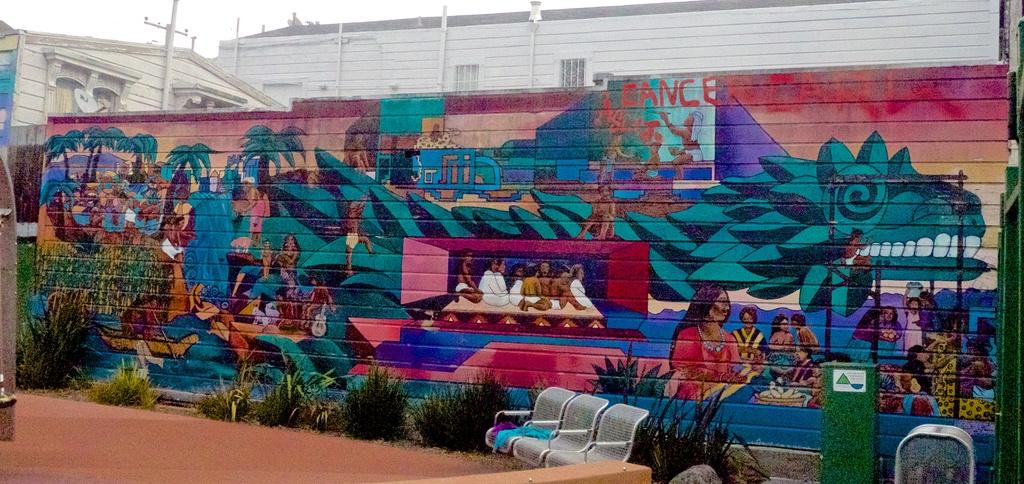What type of structures can be seen in the image? There are buildings in the image. What other elements are present in the image besides buildings? There are plants, chairs, poles, and other objects in the image. Can you describe the graffiti in the image? There is graffiti on a wall in the image. What is visible in the background of the image? The sky is visible in the background of the image. What caption is written on the graffiti in the image? There is no caption visible on the graffiti in the image; it is just a design or artwork. Can you describe the beggar sitting near the buildings in the image? There is no beggar present in the image; the conversation only focuses on the elements mentioned in the provided facts. 